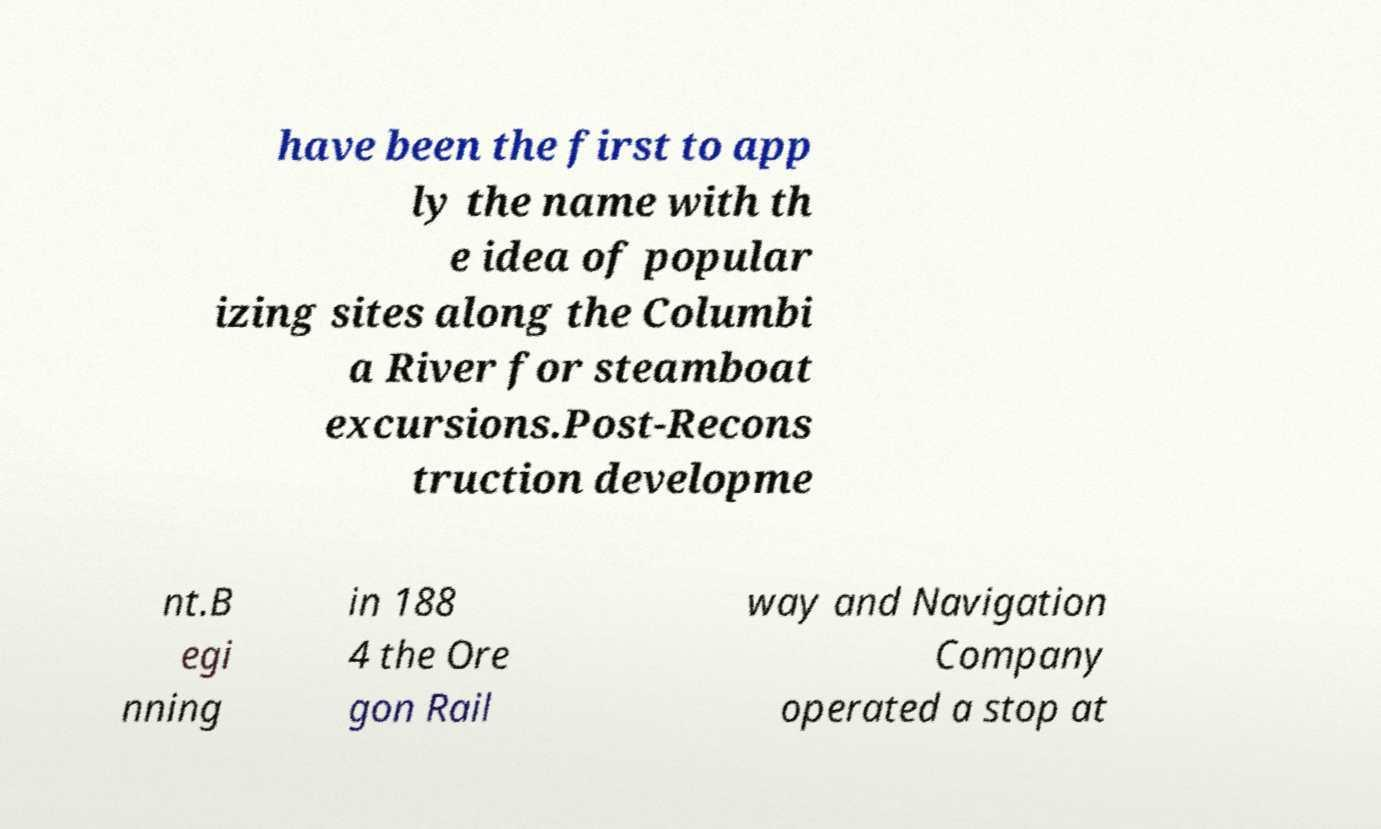Could you assist in decoding the text presented in this image and type it out clearly? have been the first to app ly the name with th e idea of popular izing sites along the Columbi a River for steamboat excursions.Post-Recons truction developme nt.B egi nning in 188 4 the Ore gon Rail way and Navigation Company operated a stop at 